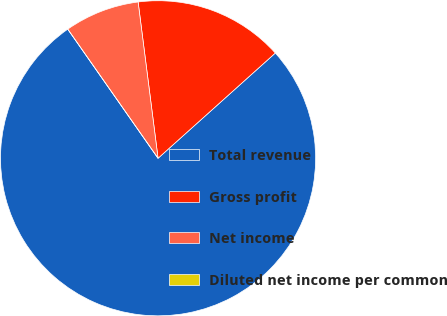Convert chart to OTSL. <chart><loc_0><loc_0><loc_500><loc_500><pie_chart><fcel>Total revenue<fcel>Gross profit<fcel>Net income<fcel>Diluted net income per common<nl><fcel>76.92%<fcel>15.38%<fcel>7.69%<fcel>0.0%<nl></chart> 